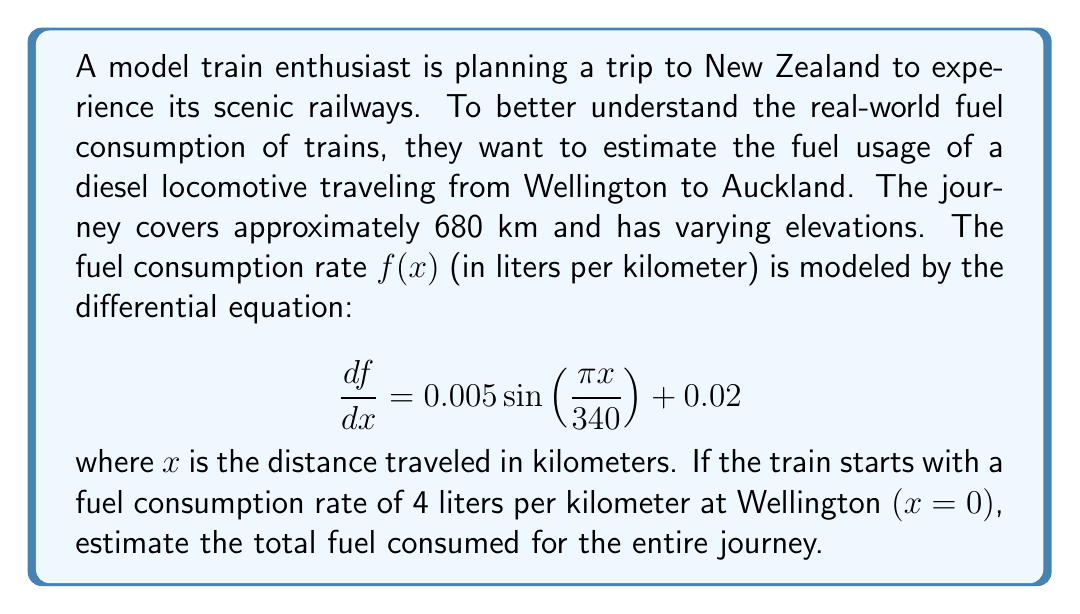Could you help me with this problem? To solve this problem, we need to follow these steps:

1) First, we need to find the function $f(x)$ by integrating the given differential equation:

   $$\frac{df}{dx} = 0.005\sin(\frac{\pi x}{340}) + 0.02$$

   Integrating both sides:

   $$f(x) = -0.005 \cdot \frac{340}{\pi} \cos(\frac{\pi x}{340}) + 0.02x + C$$

2) We can find the constant $C$ using the initial condition: $f(0) = 4$

   $$4 = -0.005 \cdot \frac{340}{\pi} \cdot 1 + 0 + C$$

   $$C = 4 + \frac{1.7}{\pi} \approx 4.54$$

3) So, our function for fuel consumption rate is:

   $$f(x) = -0.005 \cdot \frac{340}{\pi} \cos(\frac{\pi x}{340}) + 0.02x + 4.54$$

4) To find the total fuel consumed, we need to integrate this function from 0 to 680:

   $$\text{Total Fuel} = \int_0^{680} f(x) dx$$

   $$= \int_0^{680} \left[-0.005 \cdot \frac{340}{\pi} \cos(\frac{\pi x}{340}) + 0.02x + 4.54\right] dx$$

5) Solving this integral:

   $$= \left[-0.005 \cdot \frac{340^2}{\pi^2} \sin(\frac{\pi x}{340}) + 0.01x^2 + 4.54x\right]_0^{680}$$

6) Evaluating at the limits:

   $$= \left[-0.005 \cdot \frac{340^2}{\pi^2} \sin(2\pi) + 0.01(680)^2 + 4.54(680)\right] - \left[0 + 0 + 0\right]$$

   $$= 0 + 4624 + 3087.2 = 7711.2$$

Therefore, the total fuel consumed for the journey is approximately 7711.2 liters.
Answer: The total fuel consumed for the 680 km journey from Wellington to Auckland is approximately 7711.2 liters. 